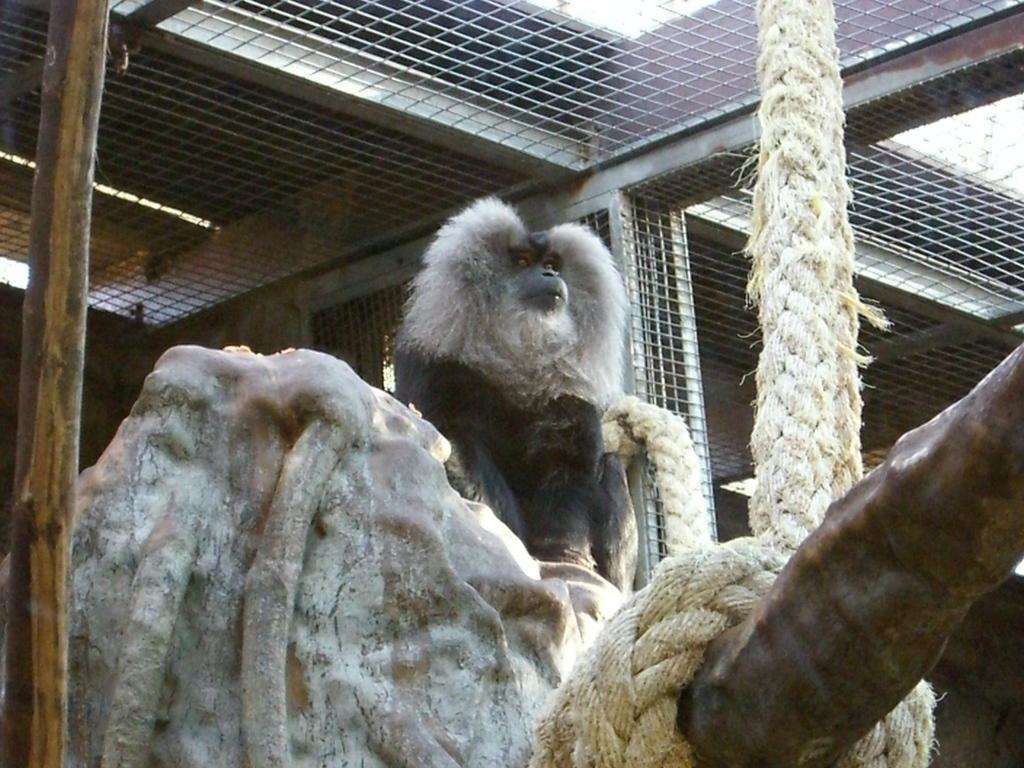What type of animal is in the image? There is a black monkey in the image. What is the monkey doing in the image? The monkey is sitting on a rock. What can be seen in the front of the image? There is a white color big rope in the front of the image. What is visible on the top of the image? There is an iron cage net visible on the top of the image. What appliance is the monkey using to turn the rope in the image? There is no appliance present in the image, and the monkey is not turning the rope. 